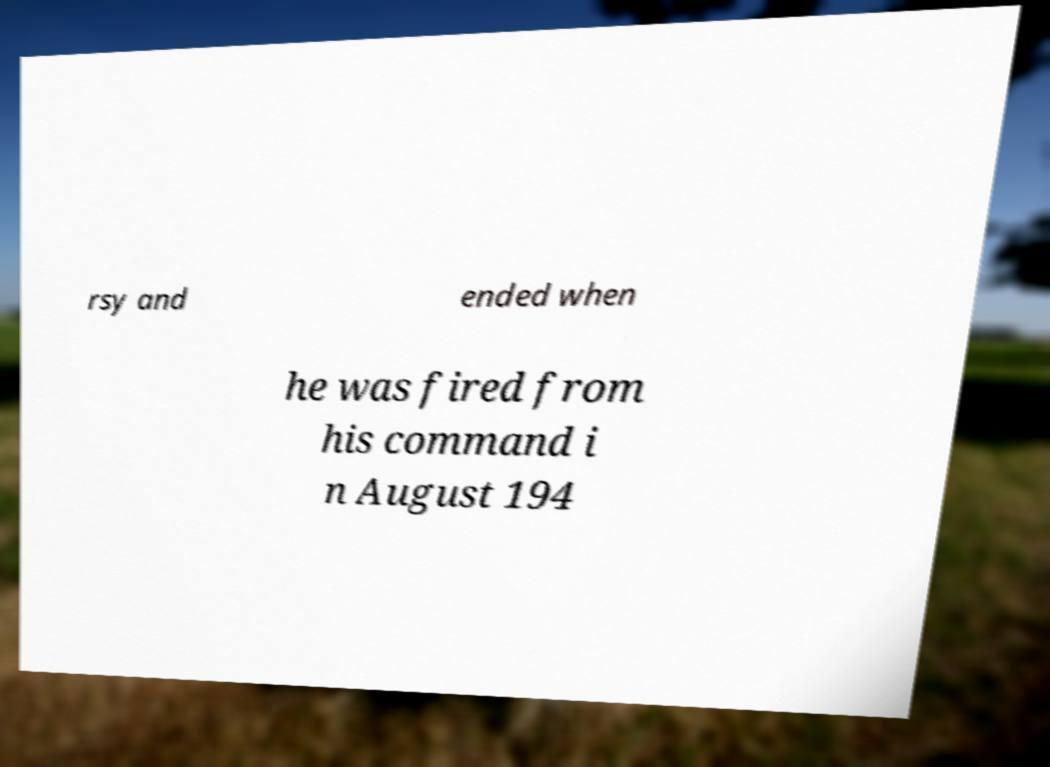Can you read and provide the text displayed in the image?This photo seems to have some interesting text. Can you extract and type it out for me? rsy and ended when he was fired from his command i n August 194 